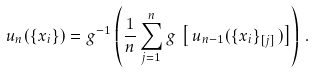<formula> <loc_0><loc_0><loc_500><loc_500>u _ { n } ( \{ x _ { i } \} ) = g ^ { - 1 } \left ( \frac { 1 } { n } \sum _ { j = 1 } ^ { n } g \, \left [ \, u _ { n - 1 } ( \{ x _ { i } \} _ { [ j ] } \, ) \right ] \right ) \, .</formula> 